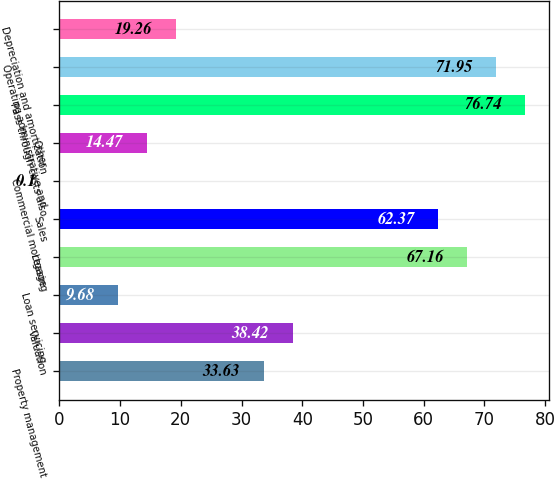<chart> <loc_0><loc_0><loc_500><loc_500><bar_chart><fcel>Property management<fcel>Valuation<fcel>Loan servicing<fcel>Leasing<fcel>Sales<fcel>Commercial mortgage<fcel>Other<fcel>Pass through costs also<fcel>Operating administrative and<fcel>Depreciation and amortization<nl><fcel>33.63<fcel>38.42<fcel>9.68<fcel>67.16<fcel>62.37<fcel>0.1<fcel>14.47<fcel>76.74<fcel>71.95<fcel>19.26<nl></chart> 